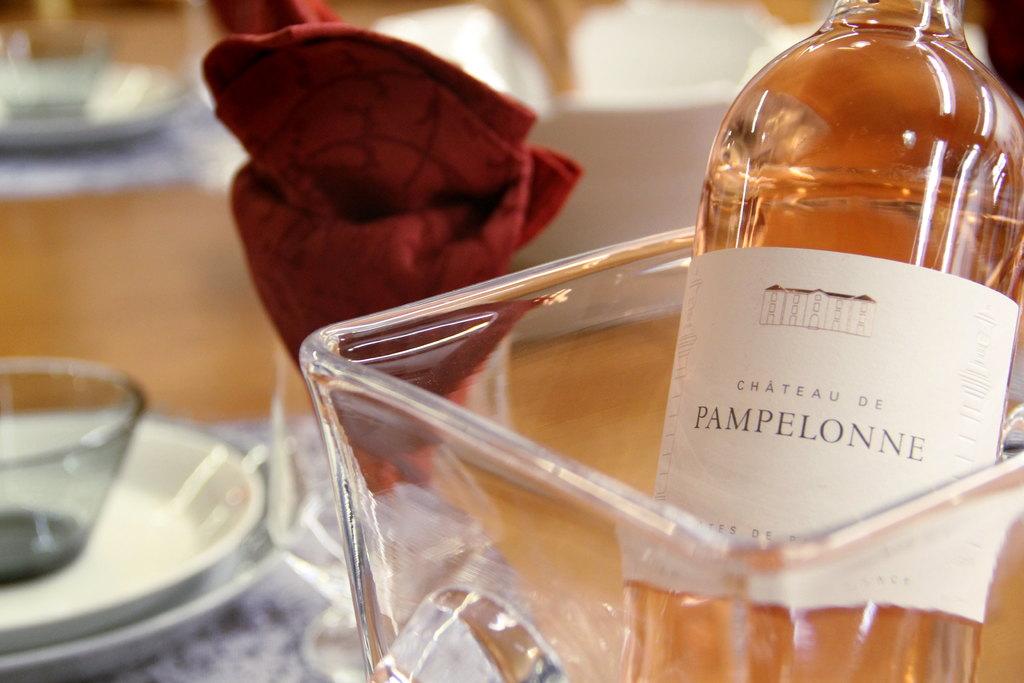What is the name of the wine?
Give a very brief answer. Chateau de pampelonne. Who produced the wine?
Your response must be concise. Chateau de pampelonne. 